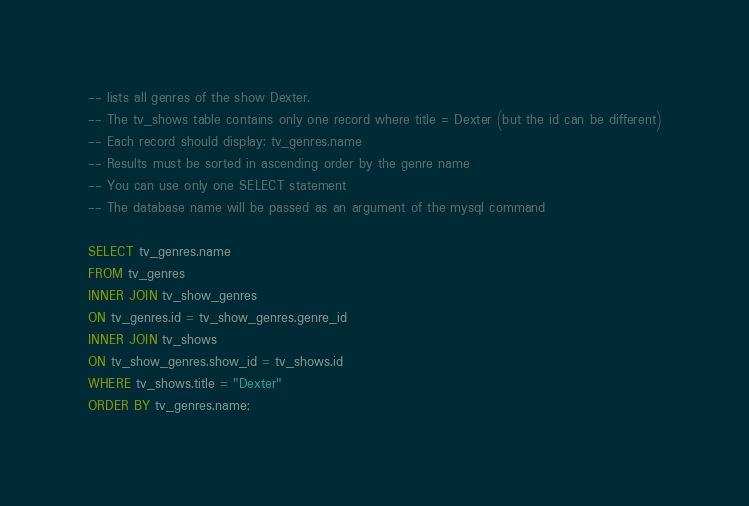<code> <loc_0><loc_0><loc_500><loc_500><_SQL_>-- lists all genres of the show Dexter.
-- The tv_shows table contains only one record where title = Dexter (but the id can be different)
-- Each record should display: tv_genres.name
-- Results must be sorted in ascending order by the genre name
-- You can use only one SELECT statement
-- The database name will be passed as an argument of the mysql command

SELECT tv_genres.name
FROM tv_genres
INNER JOIN tv_show_genres
ON tv_genres.id = tv_show_genres.genre_id
INNER JOIN tv_shows
ON tv_show_genres.show_id = tv_shows.id
WHERE tv_shows.title = "Dexter"
ORDER BY tv_genres.name;
</code> 